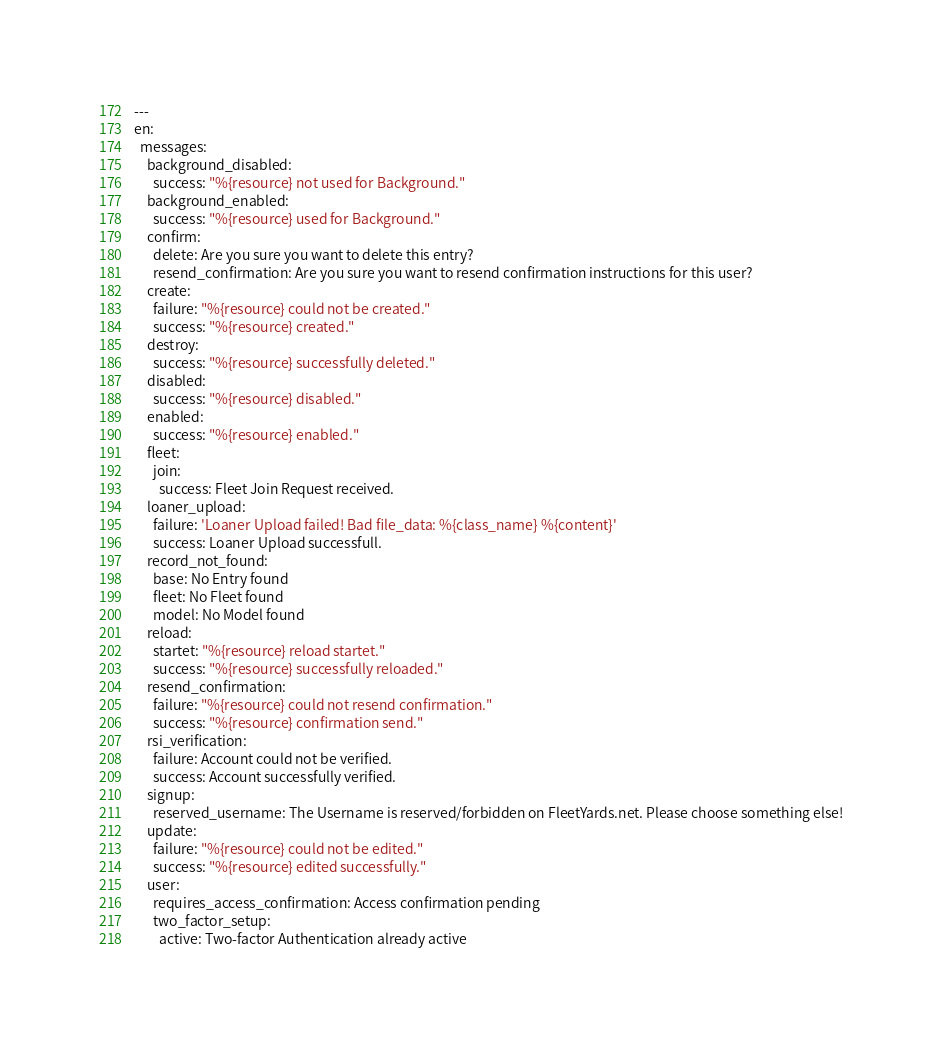<code> <loc_0><loc_0><loc_500><loc_500><_YAML_>---
en:
  messages:
    background_disabled:
      success: "%{resource} not used for Background."
    background_enabled:
      success: "%{resource} used for Background."
    confirm:
      delete: Are you sure you want to delete this entry?
      resend_confirmation: Are you sure you want to resend confirmation instructions for this user?
    create:
      failure: "%{resource} could not be created."
      success: "%{resource} created."
    destroy:
      success: "%{resource} successfully deleted."
    disabled:
      success: "%{resource} disabled."
    enabled:
      success: "%{resource} enabled."
    fleet:
      join:
        success: Fleet Join Request received.
    loaner_upload:
      failure: 'Loaner Upload failed! Bad file_data: %{class_name} %{content}'
      success: Loaner Upload successfull.
    record_not_found:
      base: No Entry found
      fleet: No Fleet found
      model: No Model found
    reload:
      startet: "%{resource} reload startet."
      success: "%{resource} successfully reloaded."
    resend_confirmation:
      failure: "%{resource} could not resend confirmation."
      success: "%{resource} confirmation send."
    rsi_verification:
      failure: Account could not be verified.
      success: Account successfully verified.
    signup:
      reserved_username: The Username is reserved/forbidden on FleetYards.net. Please choose something else!
    update:
      failure: "%{resource} could not be edited."
      success: "%{resource} edited successfully."
    user:
      requires_access_confirmation: Access confirmation pending
      two_factor_setup:
        active: Two-factor Authentication already active
</code> 